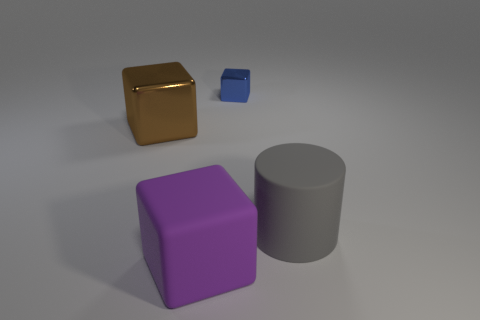What number of other objects are the same material as the brown object?
Provide a succinct answer. 1. What color is the block in front of the block that is on the left side of the large block that is in front of the large gray cylinder?
Your answer should be compact. Purple. The rubber object behind the big block that is in front of the large gray cylinder is what shape?
Give a very brief answer. Cylinder. Is the number of shiny objects in front of the blue metal block greater than the number of tiny purple spheres?
Make the answer very short. Yes. Is the shape of the large thing on the right side of the tiny blue shiny object the same as  the tiny metal object?
Ensure brevity in your answer.  No. Are there any brown things that have the same shape as the blue metallic object?
Make the answer very short. Yes. How many objects are metallic cubes that are right of the large brown thing or large purple blocks?
Ensure brevity in your answer.  2. Is the number of large purple rubber objects greater than the number of small cylinders?
Keep it short and to the point. Yes. Is there a purple matte cube that has the same size as the brown metallic thing?
Provide a short and direct response. Yes. How many objects are either objects that are left of the large purple matte block or large blocks to the left of the rubber block?
Provide a short and direct response. 1. 